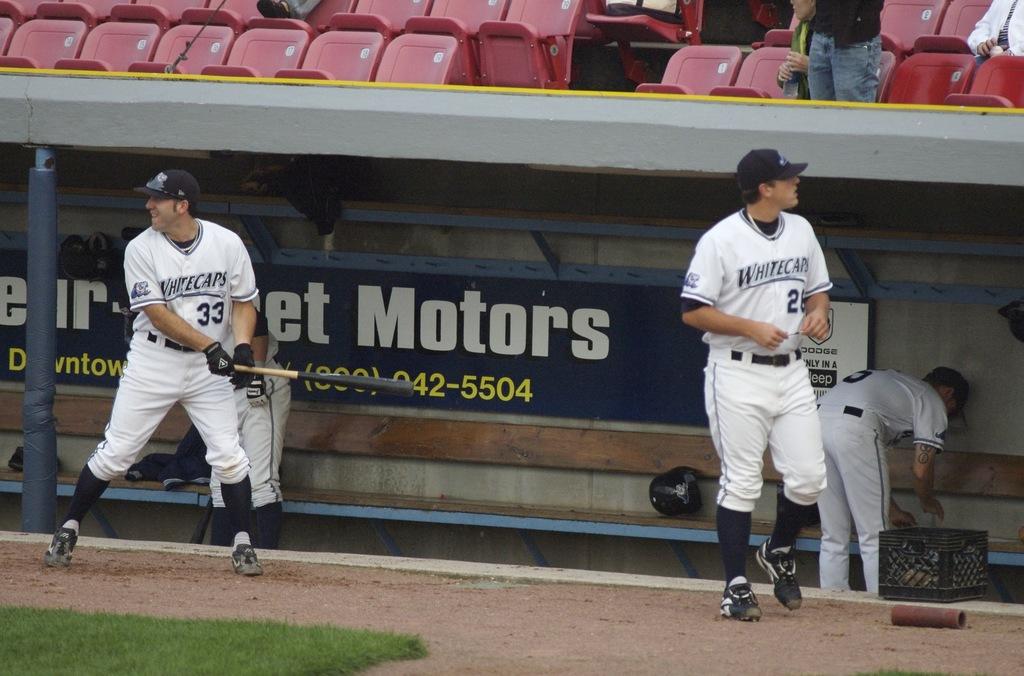What number is on the jersey of the man with a bat?
Make the answer very short. 33. 